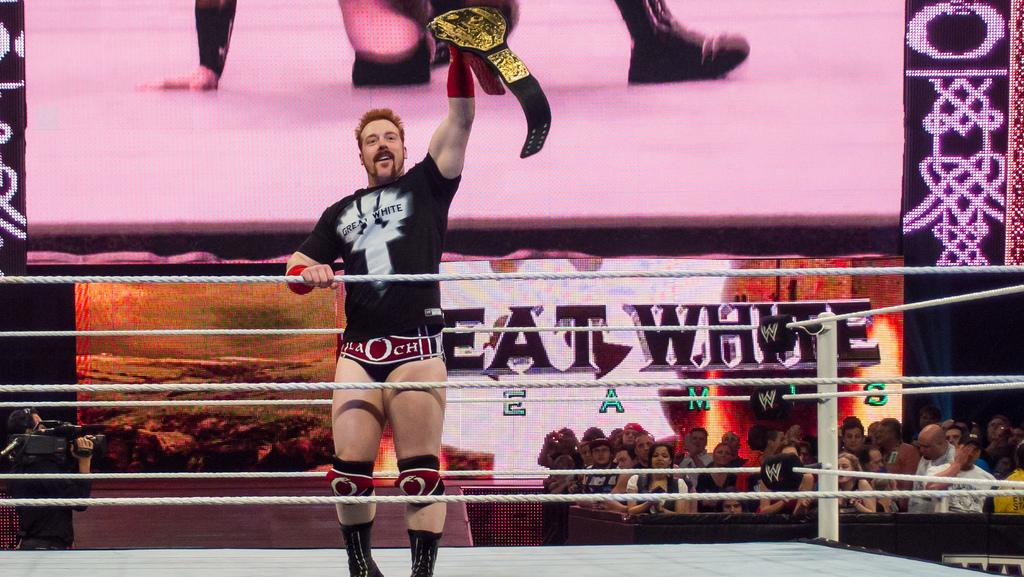<image>
Give a short and clear explanation of the subsequent image. A wrestler holds his championship belt over his head in celebration in front of a video board displaying EAT WHITE. 